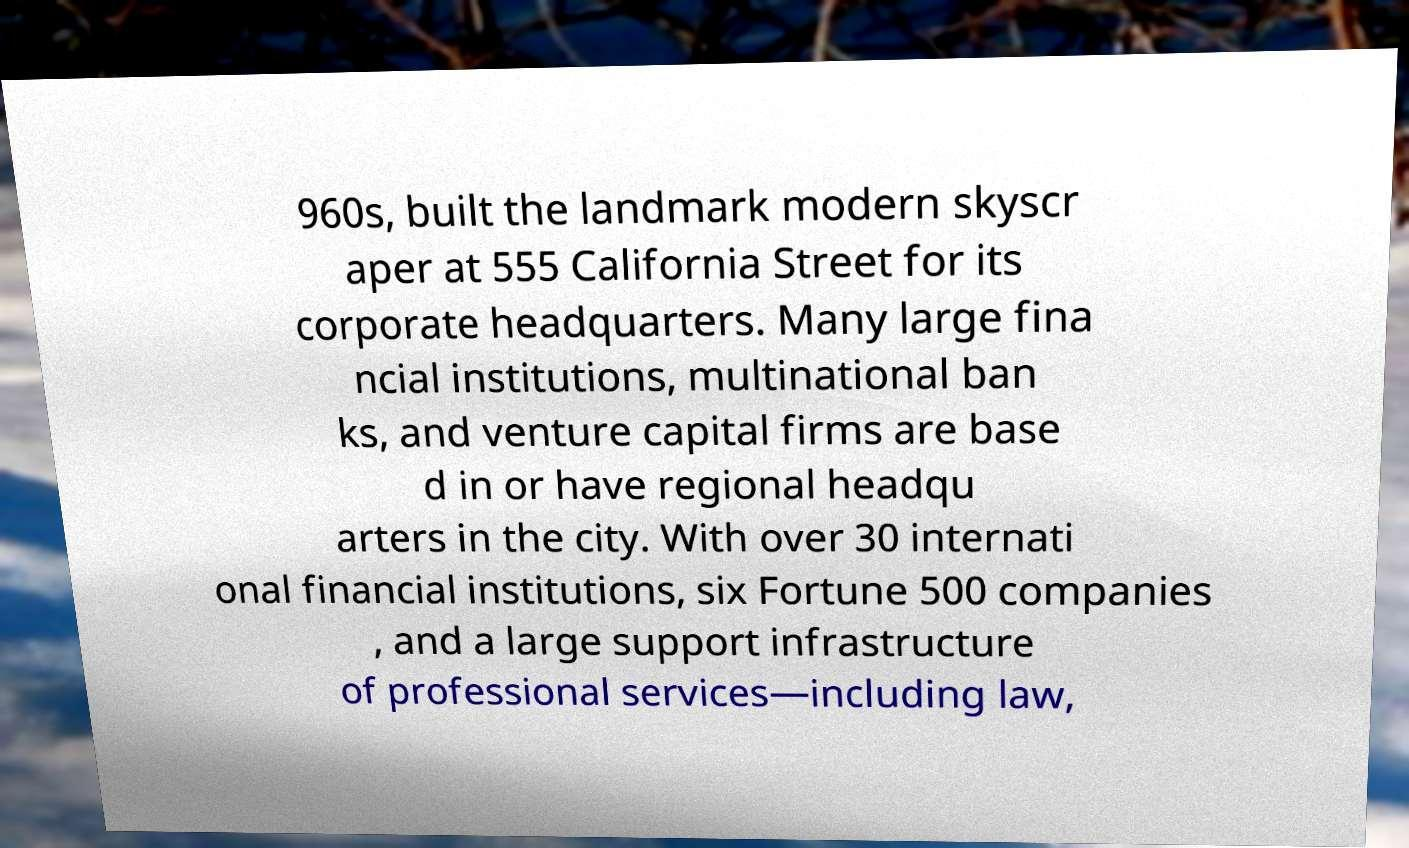I need the written content from this picture converted into text. Can you do that? 960s, built the landmark modern skyscr aper at 555 California Street for its corporate headquarters. Many large fina ncial institutions, multinational ban ks, and venture capital firms are base d in or have regional headqu arters in the city. With over 30 internati onal financial institutions, six Fortune 500 companies , and a large support infrastructure of professional services—including law, 